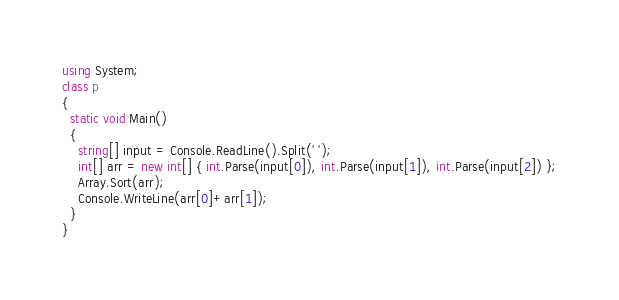Convert code to text. <code><loc_0><loc_0><loc_500><loc_500><_C#_>using System;
class p
{
  static void Main()
  {
    string[] input = Console.ReadLine().Split(' ');
    int[] arr = new int[] { int.Parse(input[0]), int.Parse(input[1]), int.Parse(input[2]) };
    Array.Sort(arr);
    Console.WriteLine(arr[0]+arr[1]);
  }
}</code> 